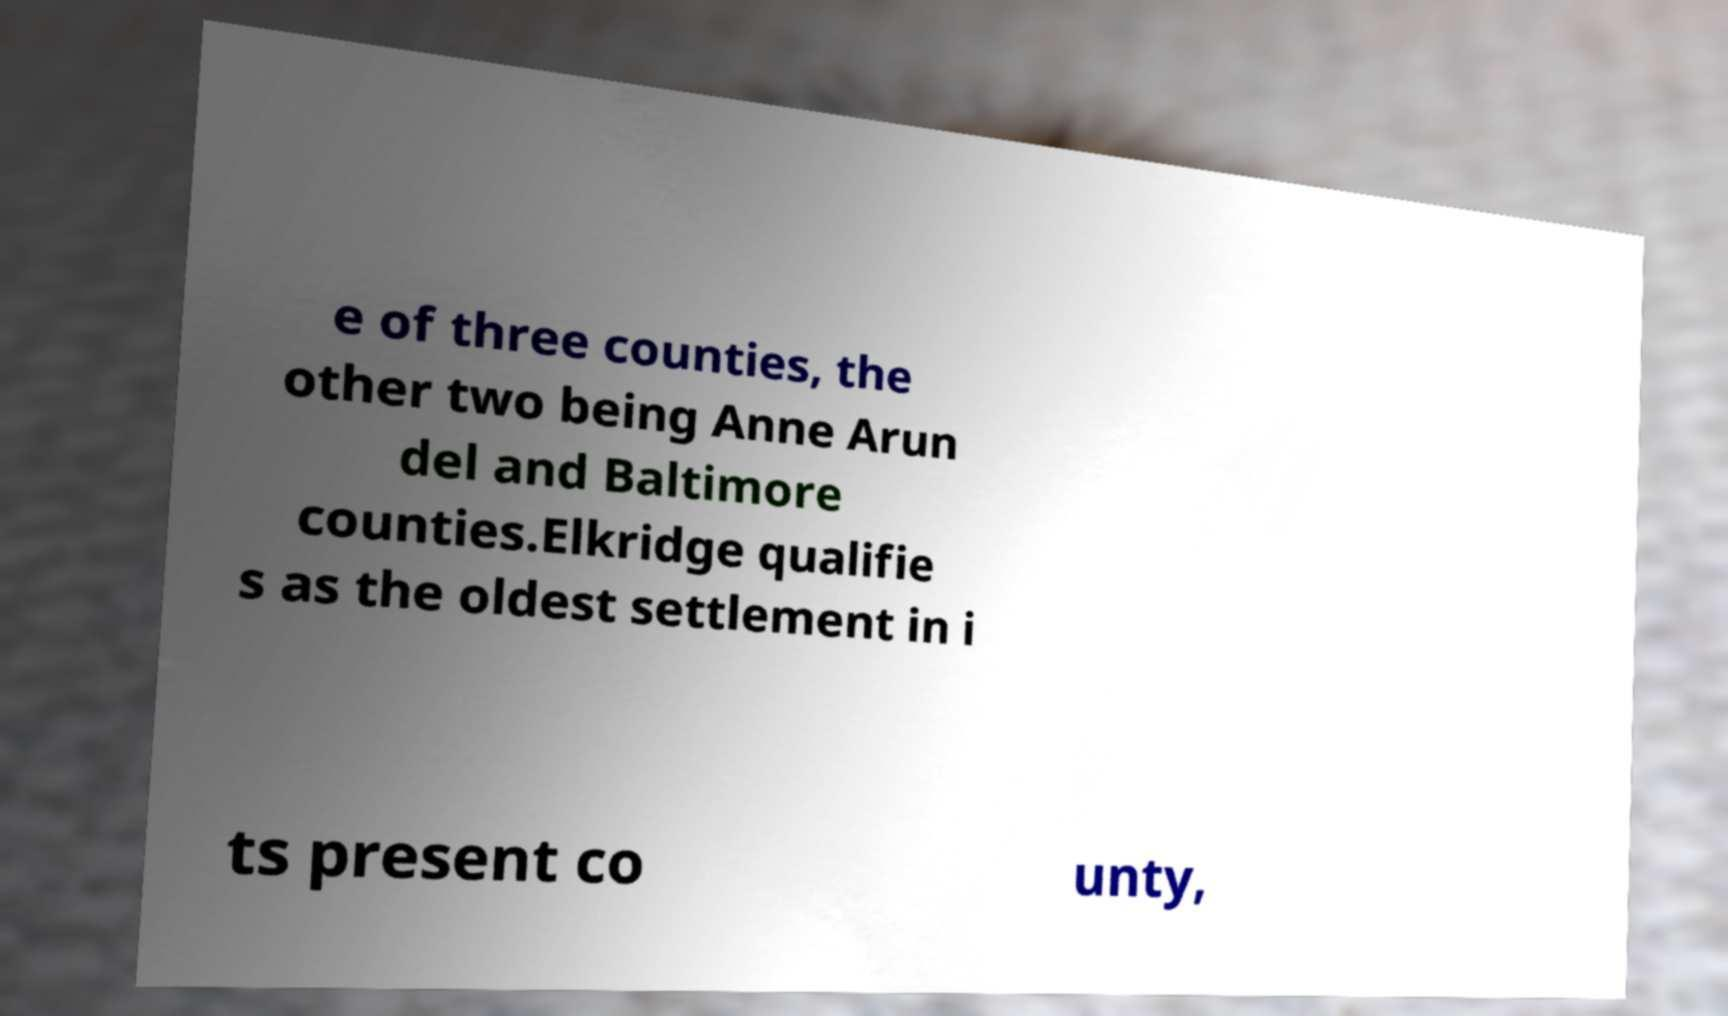What messages or text are displayed in this image? I need them in a readable, typed format. e of three counties, the other two being Anne Arun del and Baltimore counties.Elkridge qualifie s as the oldest settlement in i ts present co unty, 